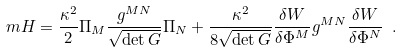<formula> <loc_0><loc_0><loc_500><loc_500>\ m H = \frac { \kappa ^ { 2 } } { 2 } \Pi _ { M } \frac { g ^ { M N } } { \sqrt { \det G } } \Pi _ { N } + \frac { \kappa ^ { 2 } } { 8 \sqrt { \det G } } \frac { \delta W } { \delta \Phi ^ { M } } g ^ { M N } \frac { \delta W } { \delta \Phi ^ { N } } \ .</formula> 